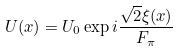<formula> <loc_0><loc_0><loc_500><loc_500>U ( x ) = U _ { 0 } \exp i \frac { \sqrt { 2 } \xi ( x ) } { F _ { \pi } }</formula> 